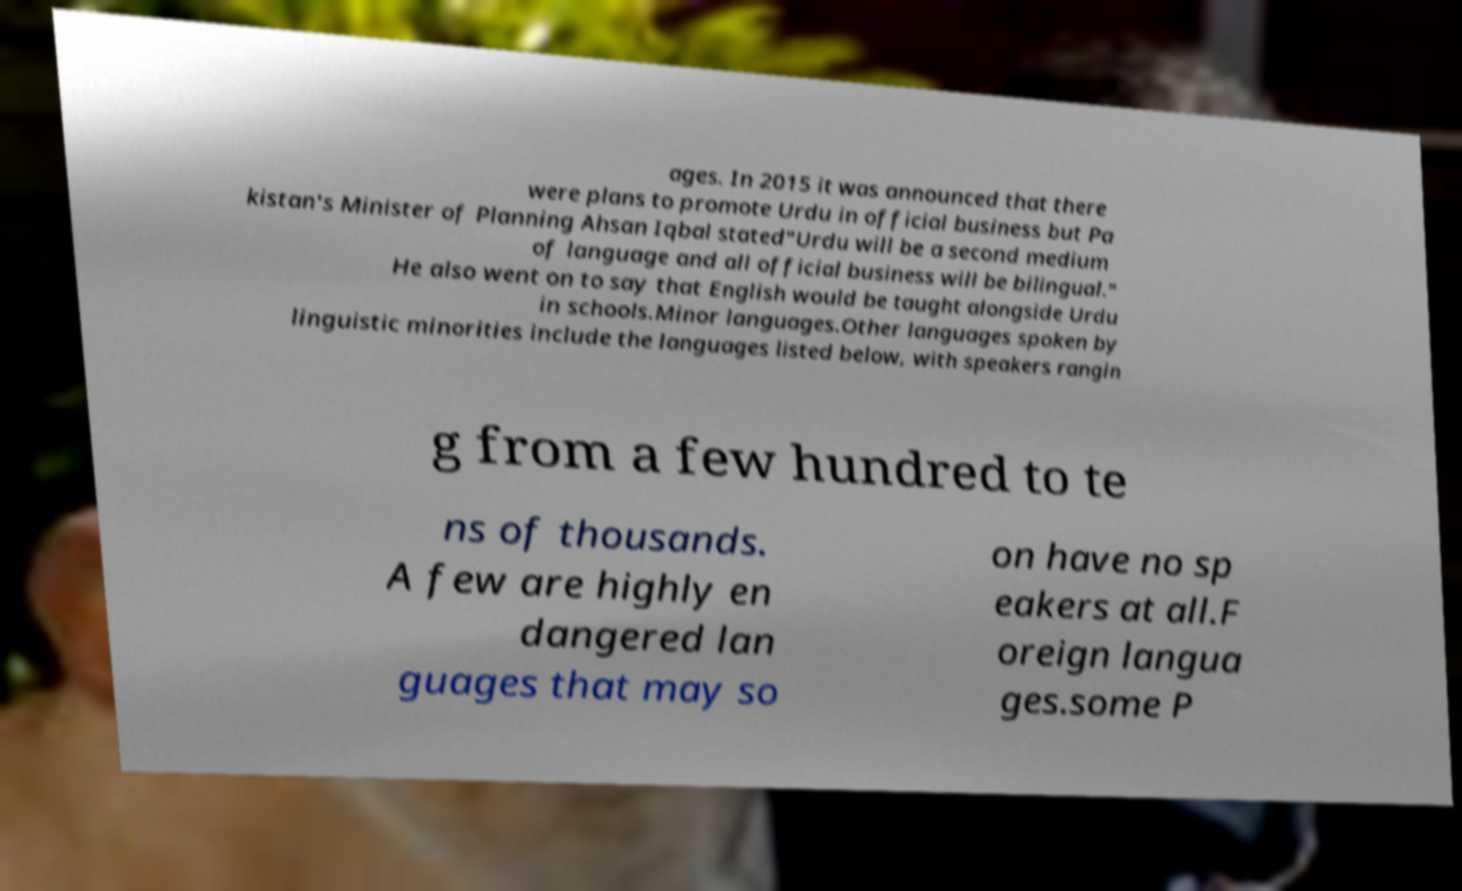There's text embedded in this image that I need extracted. Can you transcribe it verbatim? ages. In 2015 it was announced that there were plans to promote Urdu in official business but Pa kistan's Minister of Planning Ahsan Iqbal stated"Urdu will be a second medium of language and all official business will be bilingual." He also went on to say that English would be taught alongside Urdu in schools.Minor languages.Other languages spoken by linguistic minorities include the languages listed below, with speakers rangin g from a few hundred to te ns of thousands. A few are highly en dangered lan guages that may so on have no sp eakers at all.F oreign langua ges.some P 